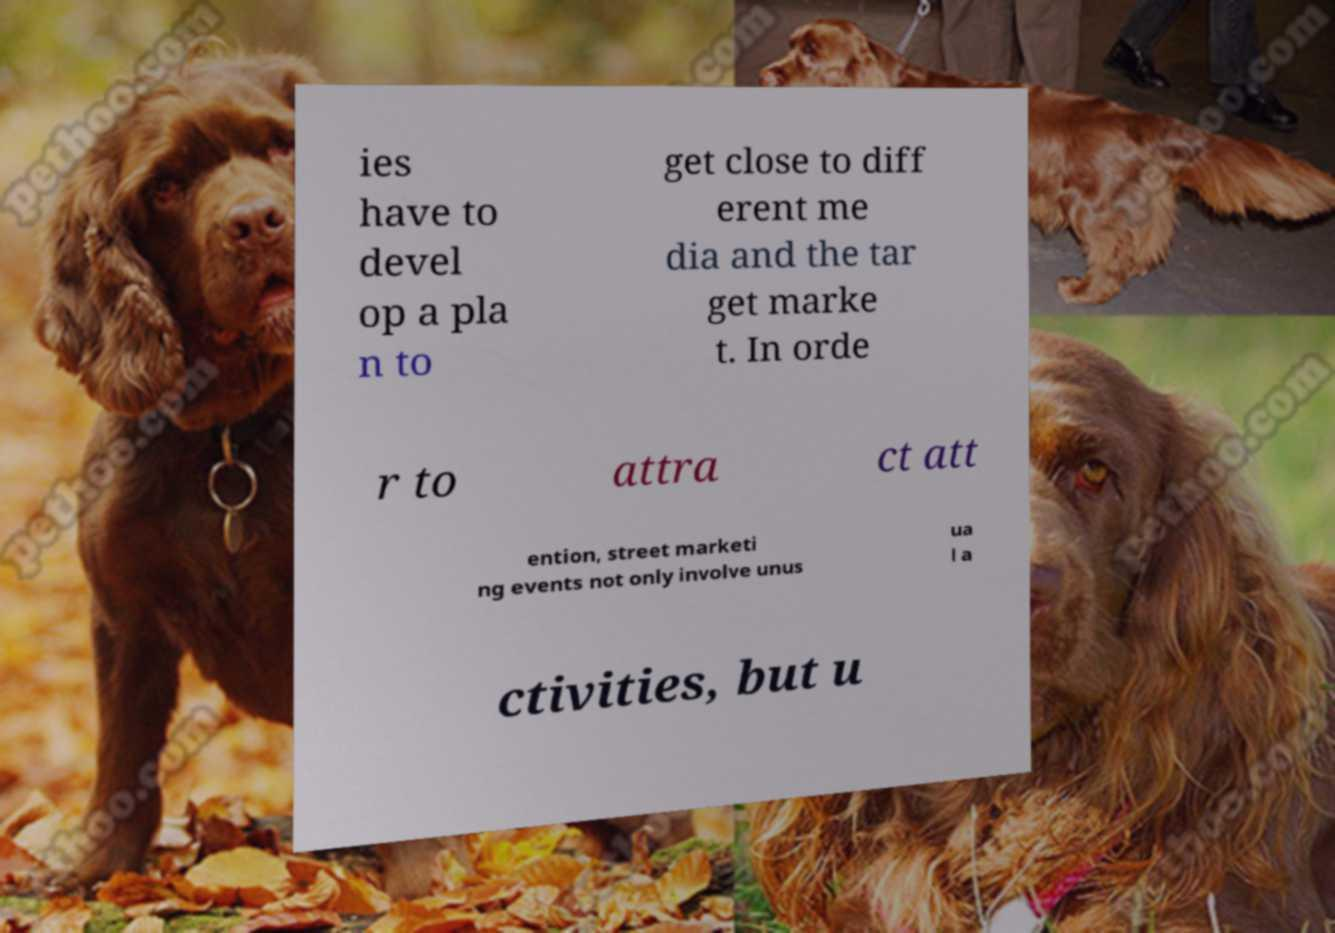I need the written content from this picture converted into text. Can you do that? ies have to devel op a pla n to get close to diff erent me dia and the tar get marke t. In orde r to attra ct att ention, street marketi ng events not only involve unus ua l a ctivities, but u 